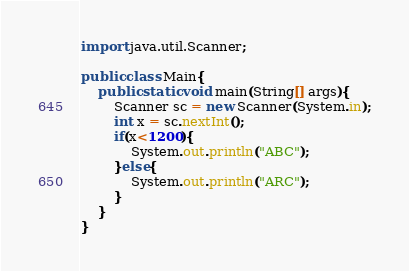<code> <loc_0><loc_0><loc_500><loc_500><_Java_>import java.util.Scanner;

public class Main{
	public static void main(String[] args){
		Scanner sc = new Scanner(System.in);
		int x = sc.nextInt();
		if(x<1200){
			System.out.println("ABC");
		}else{
			System.out.println("ARC");
		}
	}
}
</code> 